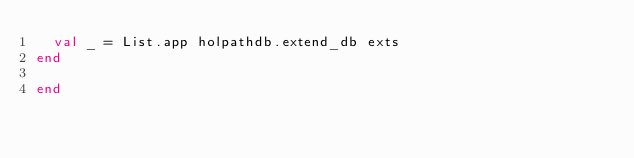Convert code to text. <code><loc_0><loc_0><loc_500><loc_500><_SML_>  val _ = List.app holpathdb.extend_db exts
end

end
</code> 